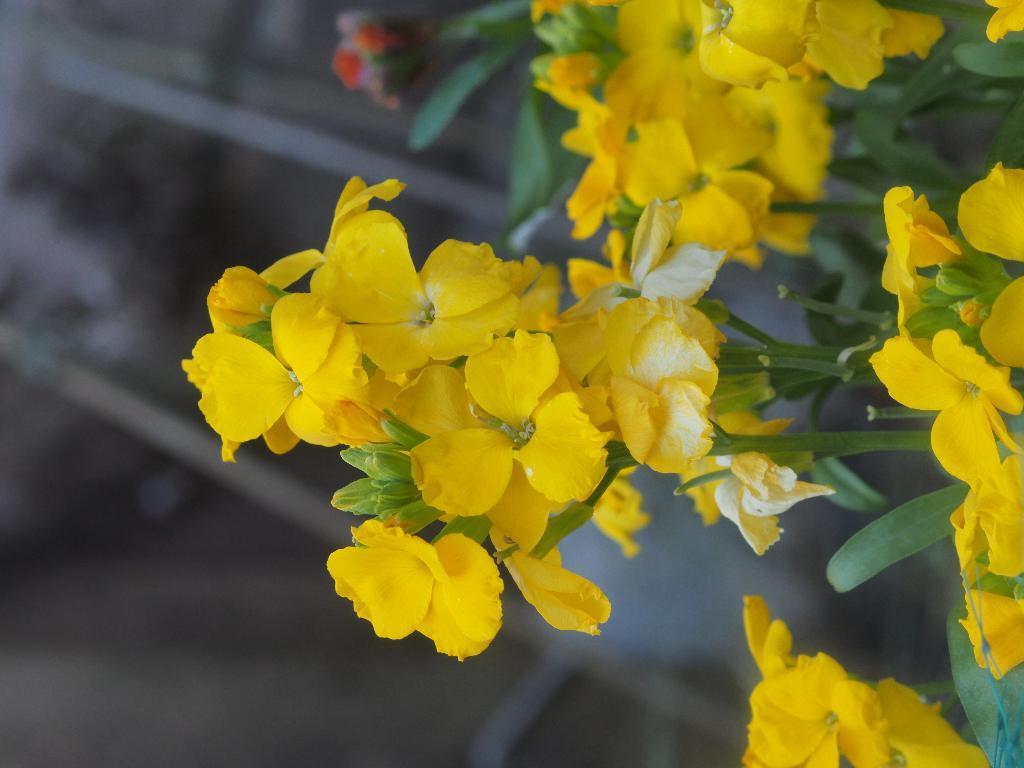Describe this image in one or two sentences. There are yellow color flowers with leaves on a stem. 